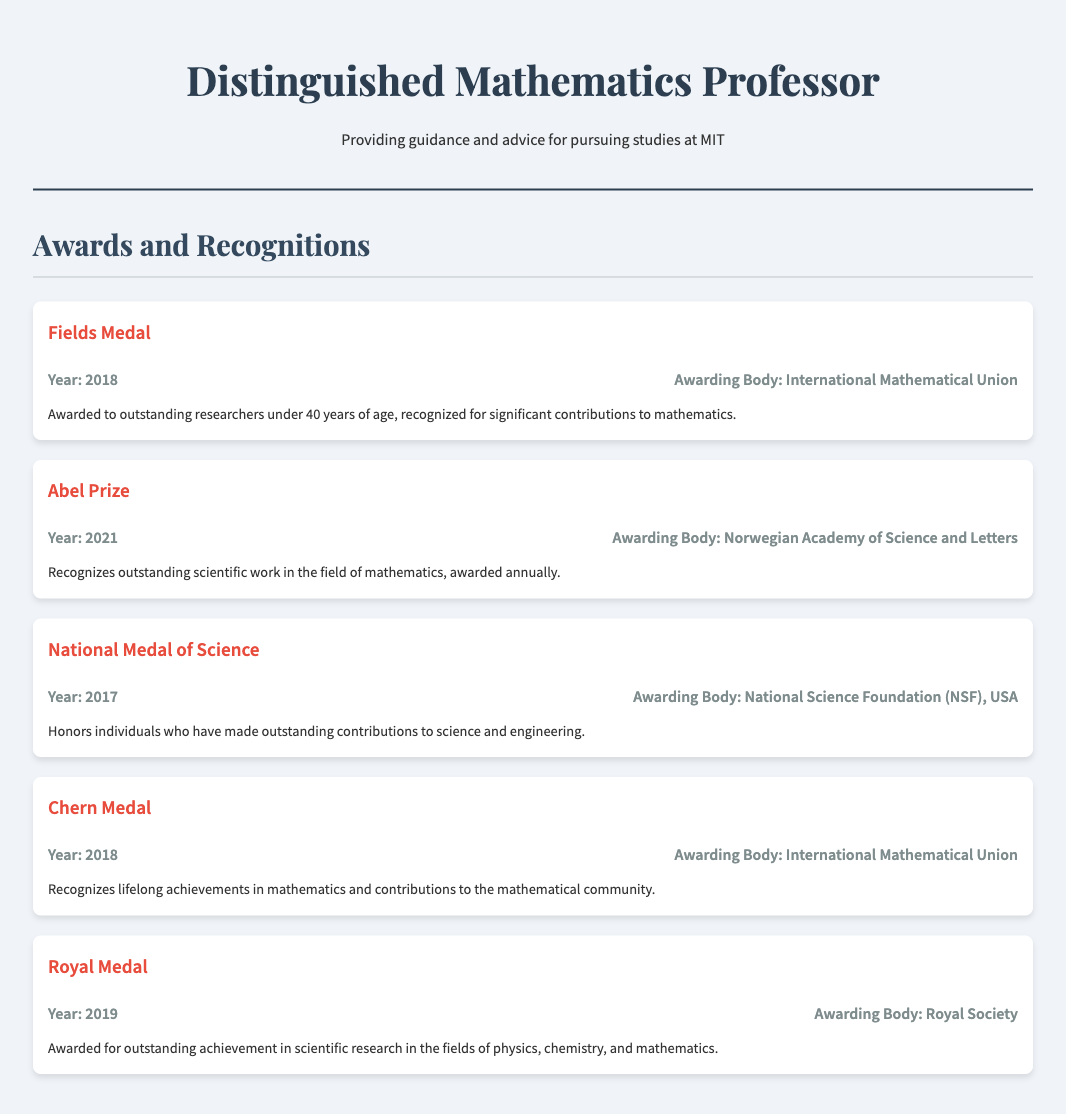what award was received in 2018? The award received in 2018 is the Fields Medal, recognized for significant contributions to mathematics.
Answer: Fields Medal who awarded the Abel Prize? The Abel Prize is awarded by the Norwegian Academy of Science and Letters.
Answer: Norwegian Academy of Science and Letters which award recognizes lifelong achievements in mathematics? The award that recognizes lifelong achievements in mathematics is the Chern Medal.
Answer: Chern Medal how many awards are listed in the document? There are five awards listed in the document under Awards and Recognitions.
Answer: Five what is the year of the National Medal of Science award? The National Medal of Science was awarded in the year 2017.
Answer: 2017 what is the purpose of the Royal Medal? The Royal Medal is awarded for outstanding achievement in scientific research in physics, chemistry, and mathematics.
Answer: Outstanding achievement in scientific research who is eligible for the Fields Medal? The Fields Medal is awarded to outstanding researchers under 40 years of age.
Answer: Researchers under 40 years of age which awarding body gives the National Medal of Science? The National Medal of Science is awarded by the National Science Foundation (NSF), USA.
Answer: National Science Foundation (NSF), USA what common aspect do the Fields Medal and Chern Medal share? Both the Fields Medal and Chern Medal recognize significant contributions and achievements in the field of mathematics.
Answer: Recognize contributions in mathematics 